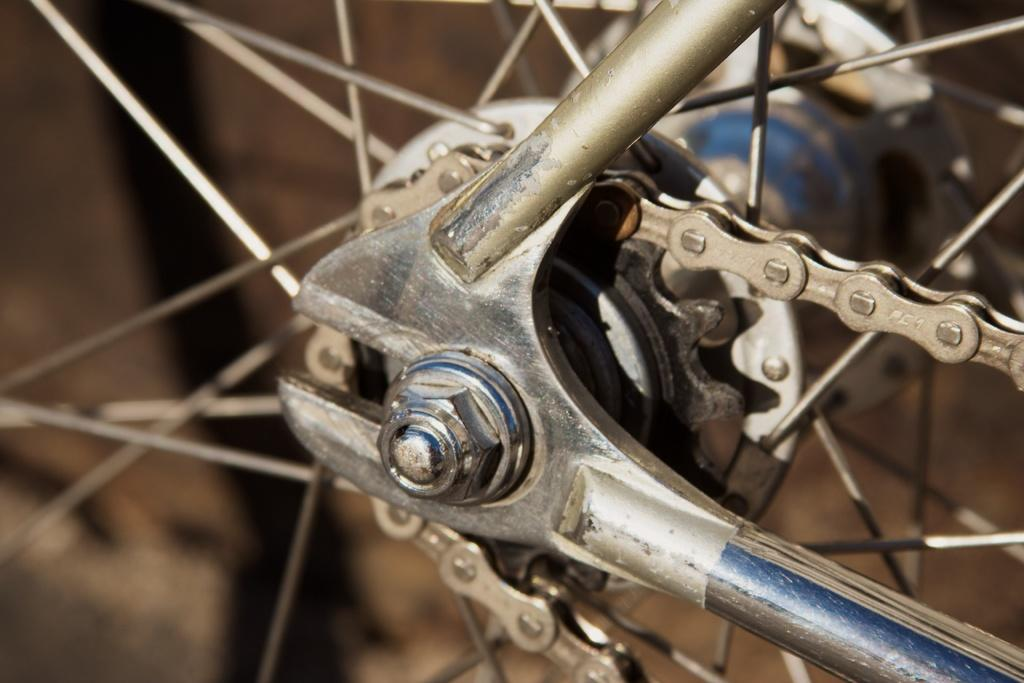What is the main object in the image? The main object in the image is a chain of a bicycle. Can you describe the chain in more detail? The chain appears to be made of metal and is connected to the bicycle's gears and pedals. What advice does the writer give in the image? There is no writer or advice present in the image; it only features a chain of a bicycle. 